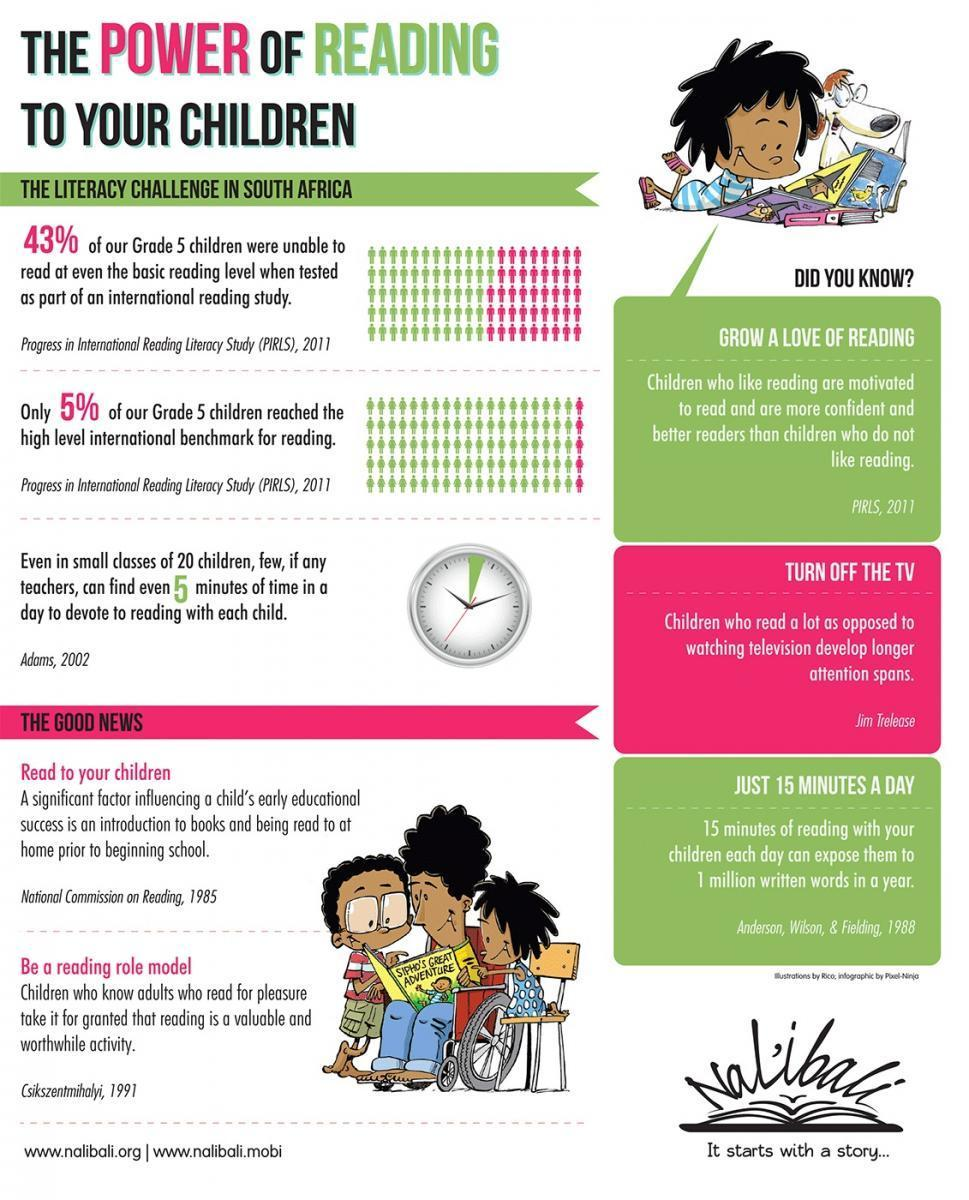How many minutes does the green portion in the clock indicate
Answer the question with a short phrase. 3 What are the 2 good news highlighted as good practice Read to your children, Be a reading role model What % of grade 5 children of South Africa were able to read the basic reading level 57 What is required daily to expose children to 1 million written words in a year 15 minutes reading with your children What is the title of the book Sipho's great adventure 